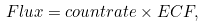<formula> <loc_0><loc_0><loc_500><loc_500>F l u x = c o u n t r a t e \times E C F ,</formula> 